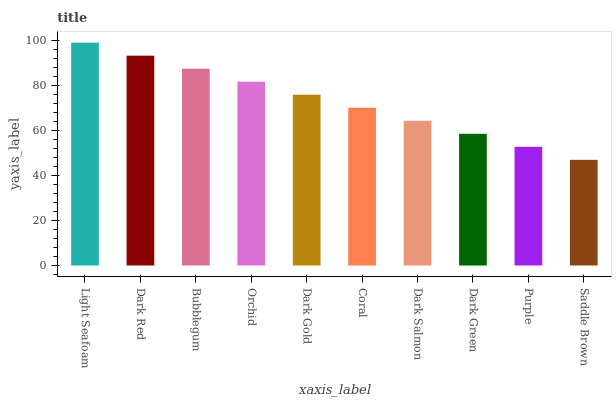Is Saddle Brown the minimum?
Answer yes or no. Yes. Is Light Seafoam the maximum?
Answer yes or no. Yes. Is Dark Red the minimum?
Answer yes or no. No. Is Dark Red the maximum?
Answer yes or no. No. Is Light Seafoam greater than Dark Red?
Answer yes or no. Yes. Is Dark Red less than Light Seafoam?
Answer yes or no. Yes. Is Dark Red greater than Light Seafoam?
Answer yes or no. No. Is Light Seafoam less than Dark Red?
Answer yes or no. No. Is Dark Gold the high median?
Answer yes or no. Yes. Is Coral the low median?
Answer yes or no. Yes. Is Orchid the high median?
Answer yes or no. No. Is Dark Green the low median?
Answer yes or no. No. 